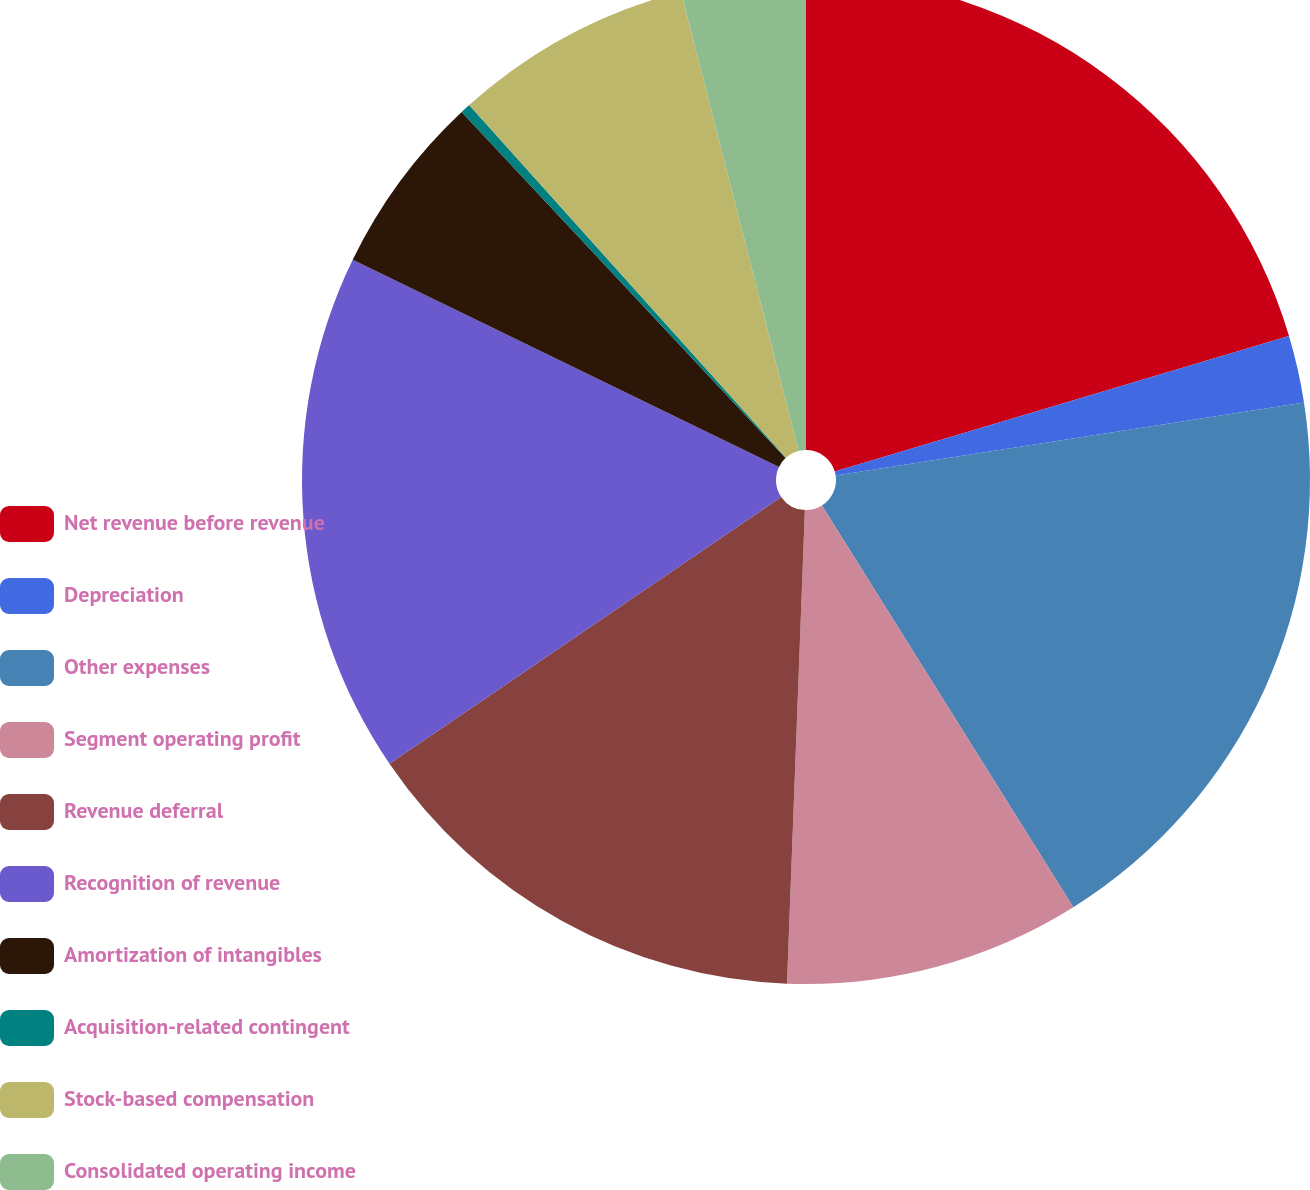<chart> <loc_0><loc_0><loc_500><loc_500><pie_chart><fcel>Net revenue before revenue<fcel>Depreciation<fcel>Other expenses<fcel>Segment operating profit<fcel>Revenue deferral<fcel>Recognition of revenue<fcel>Amortization of intangibles<fcel>Acquisition-related contingent<fcel>Stock-based compensation<fcel>Consolidated operating income<nl><fcel>20.39%<fcel>2.15%<fcel>18.56%<fcel>9.5%<fcel>14.88%<fcel>16.72%<fcel>5.83%<fcel>0.32%<fcel>7.66%<fcel>3.99%<nl></chart> 